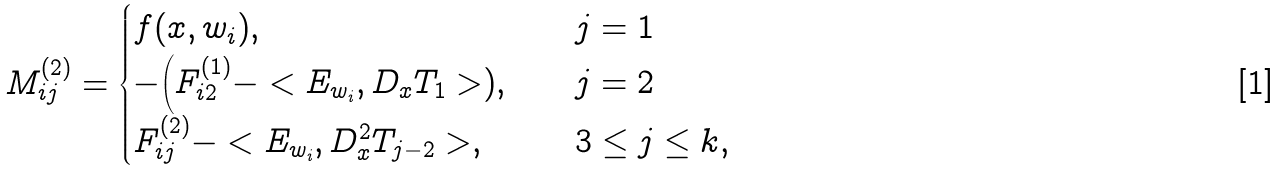Convert formula to latex. <formula><loc_0><loc_0><loc_500><loc_500>M ^ { ( 2 ) } _ { i j } = \begin{cases} f ( x , w _ { i } ) , \quad & j = 1 \\ - \Big ( F _ { i 2 } ^ { ( 1 ) } - < E _ { w _ { i } } , D _ { x } T _ { 1 } > ) , \quad & j = 2 \\ F _ { i j } ^ { ( 2 ) } - < E _ { w _ { i } } , D _ { x } ^ { 2 } T _ { j - 2 } > , \quad & 3 \leq j \leq k , \end{cases}</formula> 